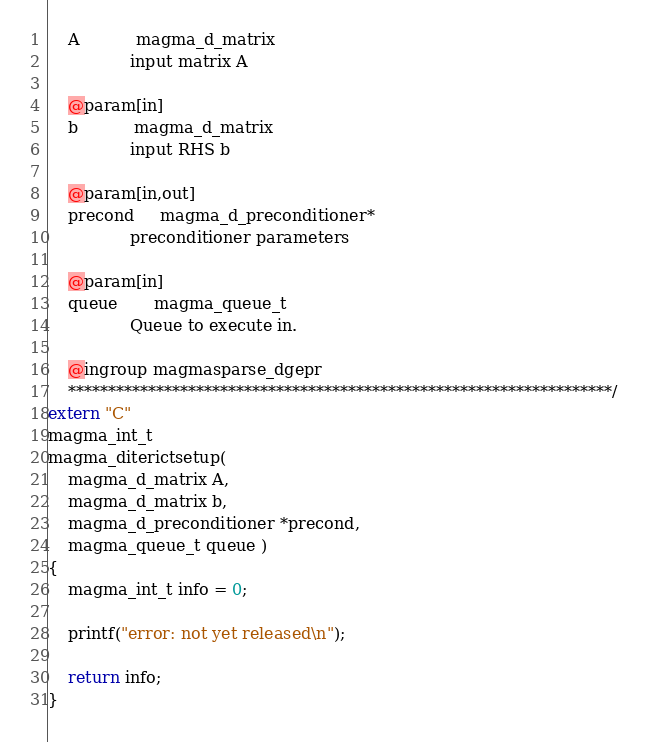<code> <loc_0><loc_0><loc_500><loc_500><_C++_>    A           magma_d_matrix
                input matrix A
                
    @param[in]
    b           magma_d_matrix
                input RHS b

    @param[in,out]
    precond     magma_d_preconditioner*
                preconditioner parameters
                
    @param[in]
    queue       magma_queue_t
                Queue to execute in.

    @ingroup magmasparse_dgepr
    ********************************************************************/
extern "C"
magma_int_t
magma_diterictsetup(
    magma_d_matrix A,
    magma_d_matrix b,
    magma_d_preconditioner *precond,
    magma_queue_t queue )
{
    magma_int_t info = 0;

    printf("error: not yet released\n");

    return info;
}
</code> 